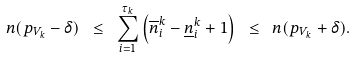<formula> <loc_0><loc_0><loc_500><loc_500>n ( p _ { V _ { k } } - \delta ) \ \leq \ \sum _ { i = 1 } ^ { \tau _ { k } } \left ( \overline { n } ^ { k } _ { i } - \underline { n } ^ { k } _ { i } + 1 \right ) \ \leq \ n ( p _ { V _ { k } } + \delta ) .</formula> 